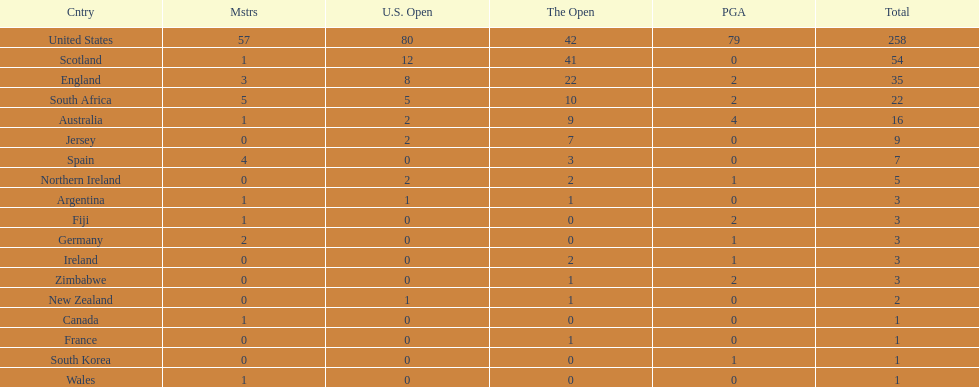Which african country has the least champion golfers according to this table? Zimbabwe. 